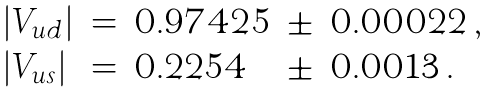Convert formula to latex. <formula><loc_0><loc_0><loc_500><loc_500>\begin{array} { l c l c l } | V _ { u d } | & = & 0 . 9 7 4 2 5 & \pm & 0 . 0 0 0 2 2 \, , \\ | V _ { u s } | & = & 0 . 2 2 5 4 & \pm & 0 . 0 0 1 3 \, . \end{array}</formula> 